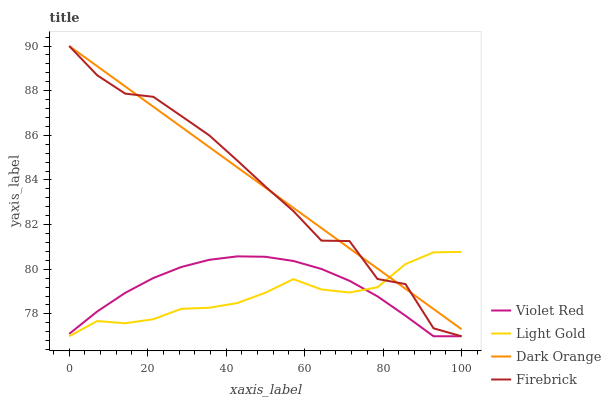Does Light Gold have the minimum area under the curve?
Answer yes or no. Yes. Does Dark Orange have the maximum area under the curve?
Answer yes or no. Yes. Does Violet Red have the minimum area under the curve?
Answer yes or no. No. Does Violet Red have the maximum area under the curve?
Answer yes or no. No. Is Dark Orange the smoothest?
Answer yes or no. Yes. Is Firebrick the roughest?
Answer yes or no. Yes. Is Violet Red the smoothest?
Answer yes or no. No. Is Violet Red the roughest?
Answer yes or no. No. Does Violet Red have the lowest value?
Answer yes or no. Yes. Does Firebrick have the highest value?
Answer yes or no. Yes. Does Light Gold have the highest value?
Answer yes or no. No. Is Violet Red less than Dark Orange?
Answer yes or no. Yes. Is Dark Orange greater than Violet Red?
Answer yes or no. Yes. Does Dark Orange intersect Light Gold?
Answer yes or no. Yes. Is Dark Orange less than Light Gold?
Answer yes or no. No. Is Dark Orange greater than Light Gold?
Answer yes or no. No. Does Violet Red intersect Dark Orange?
Answer yes or no. No. 